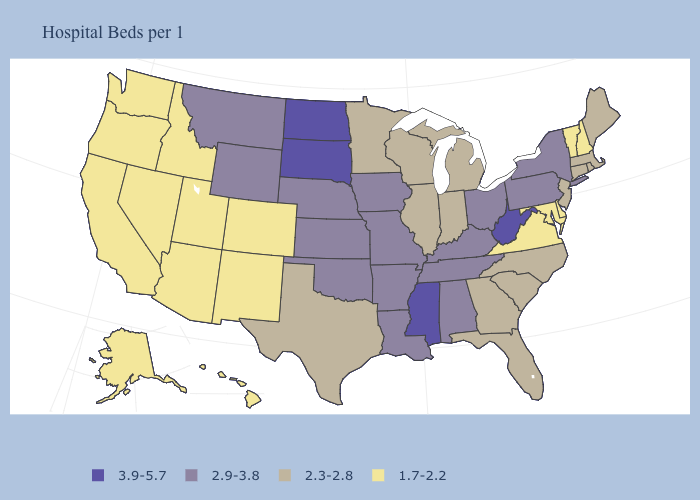What is the value of South Carolina?
Quick response, please. 2.3-2.8. Does New Mexico have the lowest value in the USA?
Answer briefly. Yes. Which states hav the highest value in the MidWest?
Give a very brief answer. North Dakota, South Dakota. Does Montana have a higher value than Kentucky?
Write a very short answer. No. What is the value of South Carolina?
Answer briefly. 2.3-2.8. Which states have the lowest value in the Northeast?
Quick response, please. New Hampshire, Vermont. Which states have the lowest value in the USA?
Keep it brief. Alaska, Arizona, California, Colorado, Delaware, Hawaii, Idaho, Maryland, Nevada, New Hampshire, New Mexico, Oregon, Utah, Vermont, Virginia, Washington. What is the value of Indiana?
Answer briefly. 2.3-2.8. Does Virginia have a lower value than Ohio?
Be succinct. Yes. What is the value of New Jersey?
Concise answer only. 2.3-2.8. Does Oregon have the same value as Colorado?
Answer briefly. Yes. What is the value of New Hampshire?
Give a very brief answer. 1.7-2.2. Which states have the highest value in the USA?
Give a very brief answer. Mississippi, North Dakota, South Dakota, West Virginia. Name the states that have a value in the range 3.9-5.7?
Give a very brief answer. Mississippi, North Dakota, South Dakota, West Virginia. 